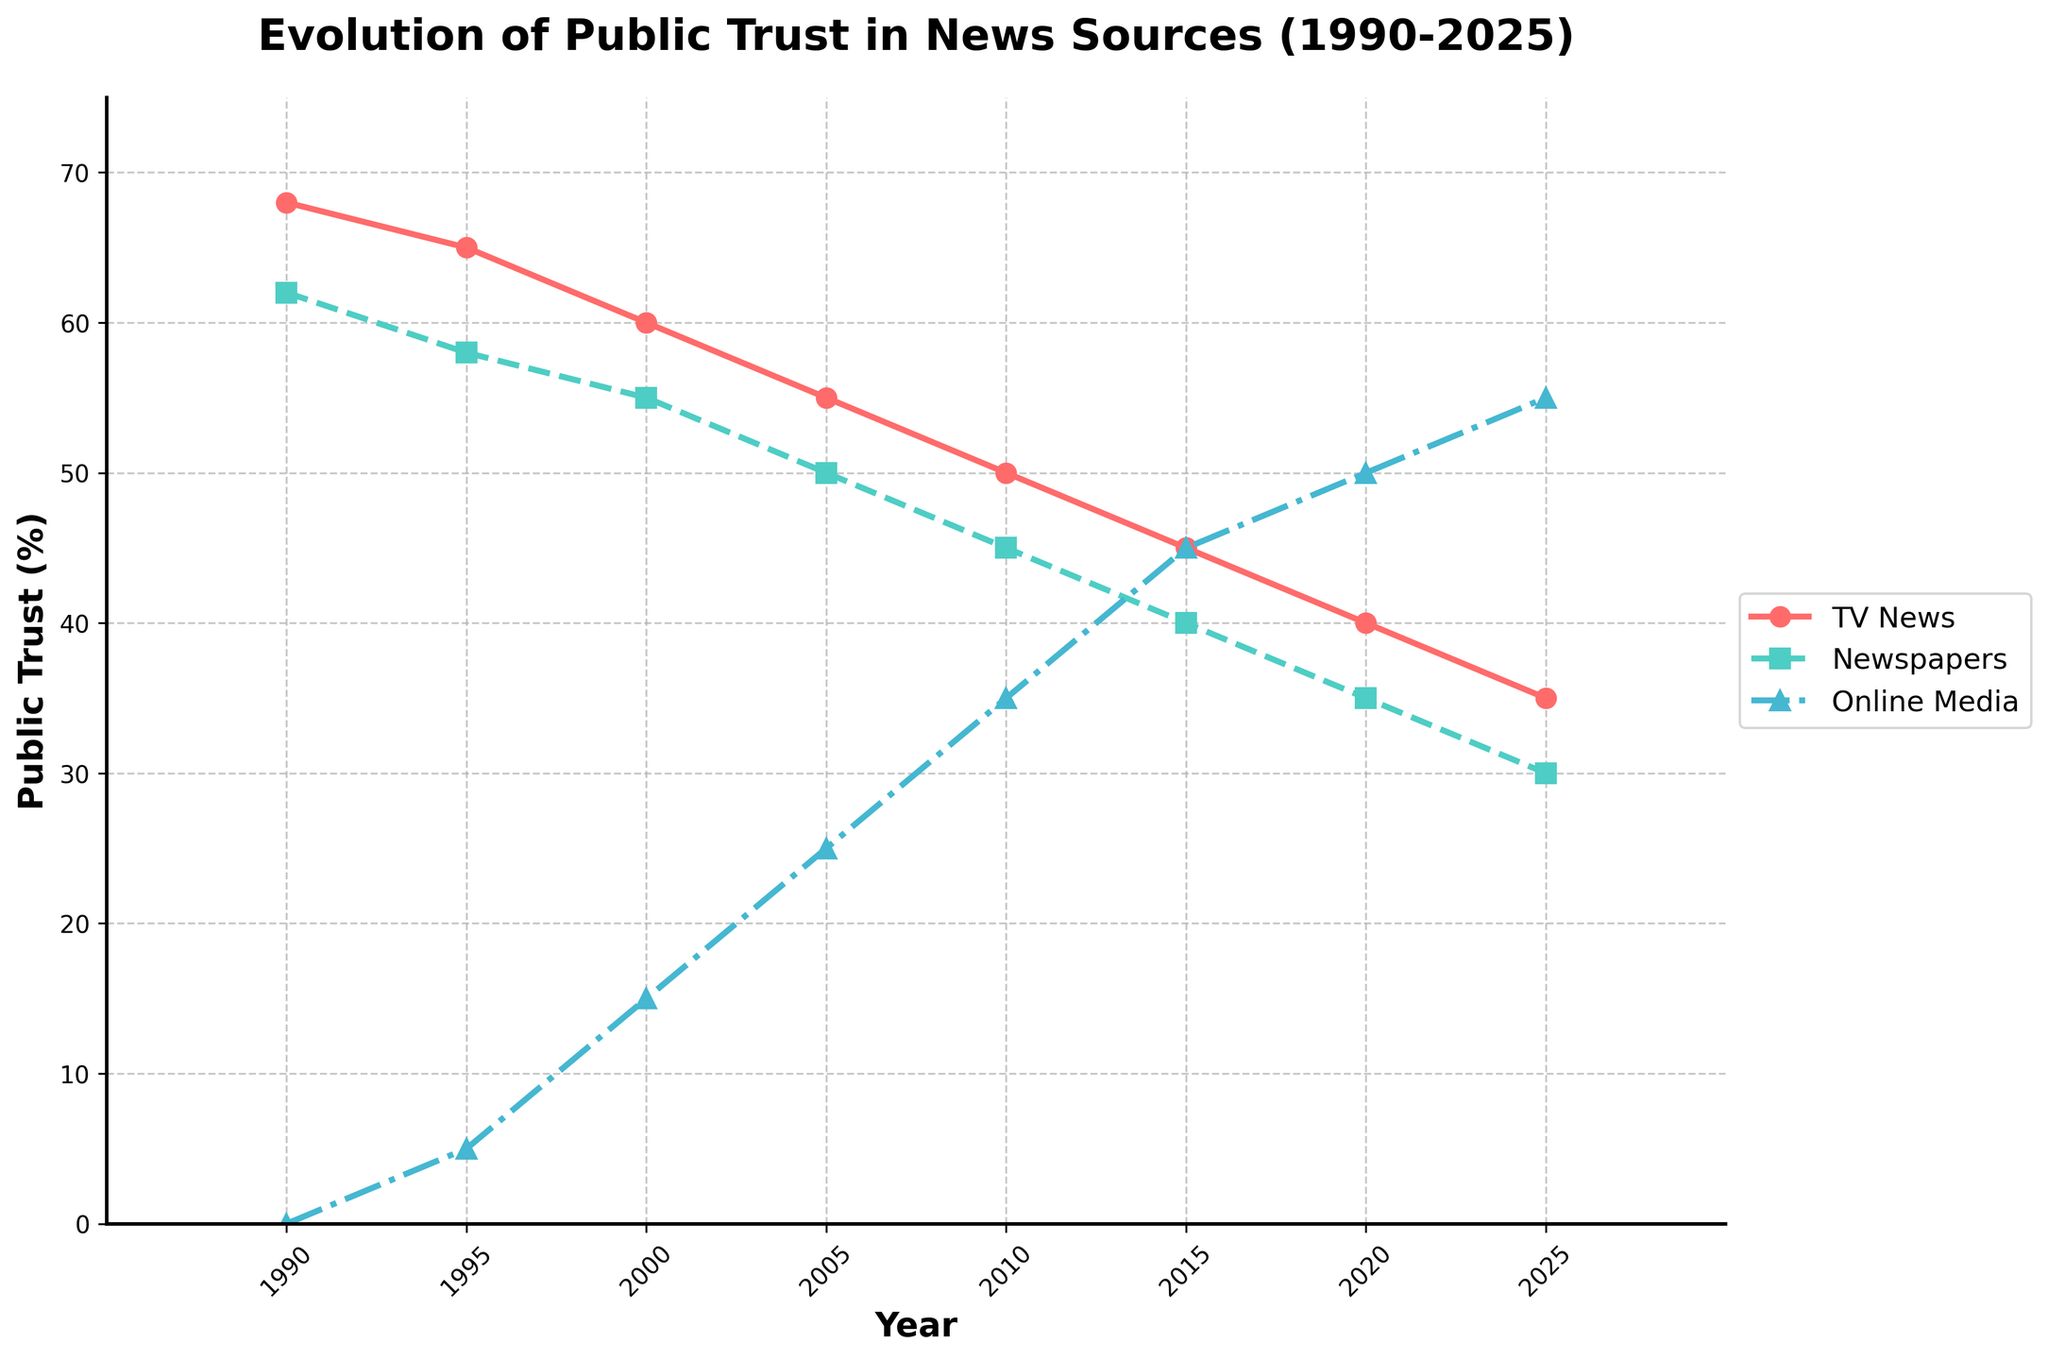What is the general trend for public trust in TV News from 1990 to 2025? Public trust in TV News shows a continuous decline from 68% in 1990 to 35% in 2025. By observing the line representing TV News on the chart, it consistently goes down over the years.
Answer: Continuous decline Which news source had the highest public trust in 2005? In 2005, TV News had the highest public trust at 55%. By looking at the three lines for 2005, the line for TV News is positioned highest on the chart.
Answer: TV News How much did public trust in Newspapers drop from 1990 to 2025? From 1990 to 2025, public trust in Newspapers dropped from 62% to 30%. The difference is calculated as 62 - 30 = 32%.
Answer: 32% What is the relative increase in public trust for Online Media between their first recorded value and the year 2025? In 1995, the first recorded value for Online Media was 5%. By 2025, it increased to 55%. To find the increase, we calculate 55 - 5 = 50%, which represents the absolute increase.
Answer: 50% Between which consecutive years did TV News see the largest drop in public trust? To find the largest drop, we look at differences between consecutive points for TV News: from 68 to 65 (3), 65 to 60 (5), 60 to 55 (5), 55 to 50 (5), 50 to 45 (5), 45 to 40 (5), and 40 to 35 (5). The largest drops are all equal at 5% and occurred in multiple intervals.
Answer: 1995-2000, 2000-2005, 2005-2010, 2010-2015, 2015-2020, 2020-2025 What was the average public trust in Online Media over the sampled years? The values for Online Media are 0, 5, 15, 25, 35, 45, 50, and 55. Summing these values gives 230. There are 8 data points, so the average is 230 / 8 = 28.75%.
Answer: 28.75% In which year did Online Media surpass Newspapers in public trust? They surpassed in 2015. By observing the crossing point, the value for Online Media (45%) exceeds Newspapers (40%).
Answer: 2015 Looking at 2025, how does the public trust in TV News compare to Online Media? In 2025, public trust in TV News is 35%, whereas for Online Media, it is 55%. Therefore, Online Media is trusted significantly more.
Answer: Online Media is trusted more What is the sum of public trust percentages for all three news sources in 2020? The values for 2020 are 40 (TV News), 35 (Newspapers), and 50 (Online Media). The sum is 40 + 35 + 50 = 125%.
Answer: 125% How did the gap between public trust in TV News and Newspapers change from 1990 to 2025? In 1990, the gap was 68 (TV News) - 62 (Newspapers) = 6%. In 2025, the gap is 35 (TV News) - 30 (Newspapers) = 5%. The gap decreased by 1%.
Answer: Decreased by 1% 